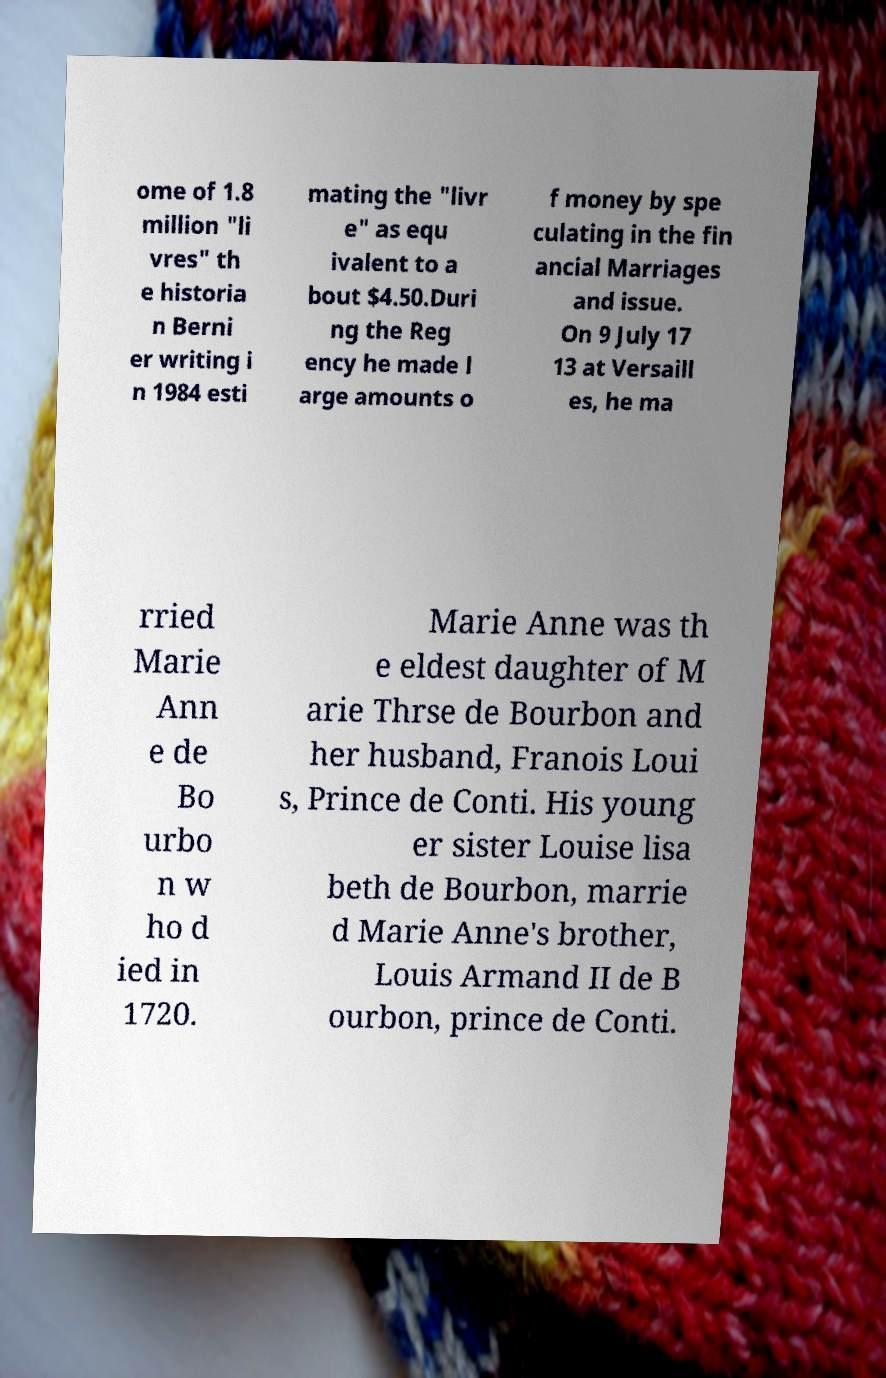Please read and relay the text visible in this image. What does it say? ome of 1.8 million "li vres" th e historia n Berni er writing i n 1984 esti mating the "livr e" as equ ivalent to a bout $4.50.Duri ng the Reg ency he made l arge amounts o f money by spe culating in the fin ancial Marriages and issue. On 9 July 17 13 at Versaill es, he ma rried Marie Ann e de Bo urbo n w ho d ied in 1720. Marie Anne was th e eldest daughter of M arie Thrse de Bourbon and her husband, Franois Loui s, Prince de Conti. His young er sister Louise lisa beth de Bourbon, marrie d Marie Anne's brother, Louis Armand II de B ourbon, prince de Conti. 